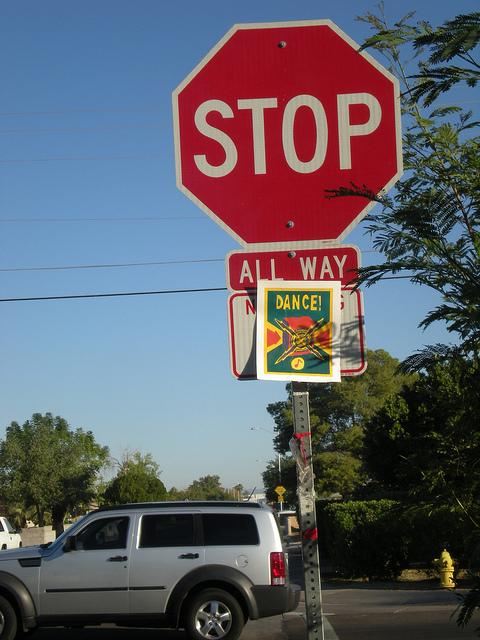How many people must stop at the intersection? all 